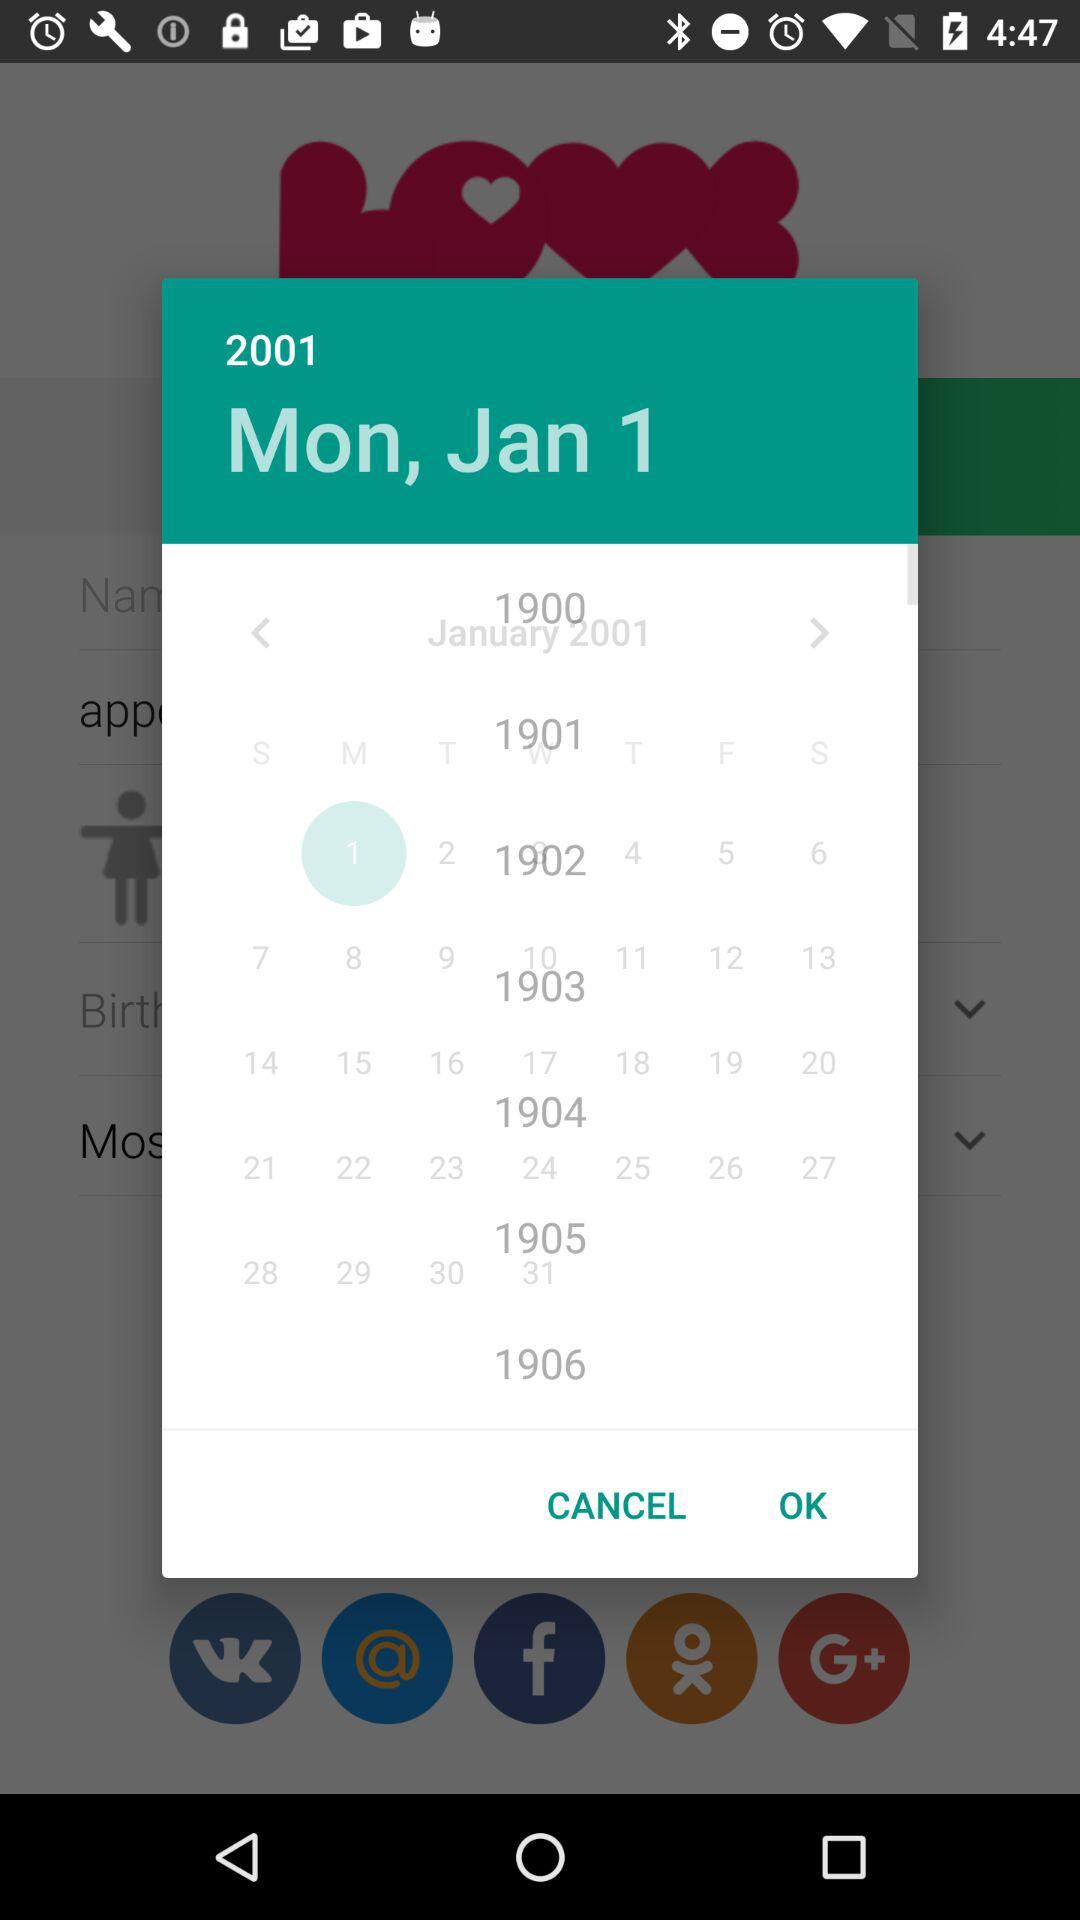What is the user's name?
When the provided information is insufficient, respond with <no answer>. <no answer> 